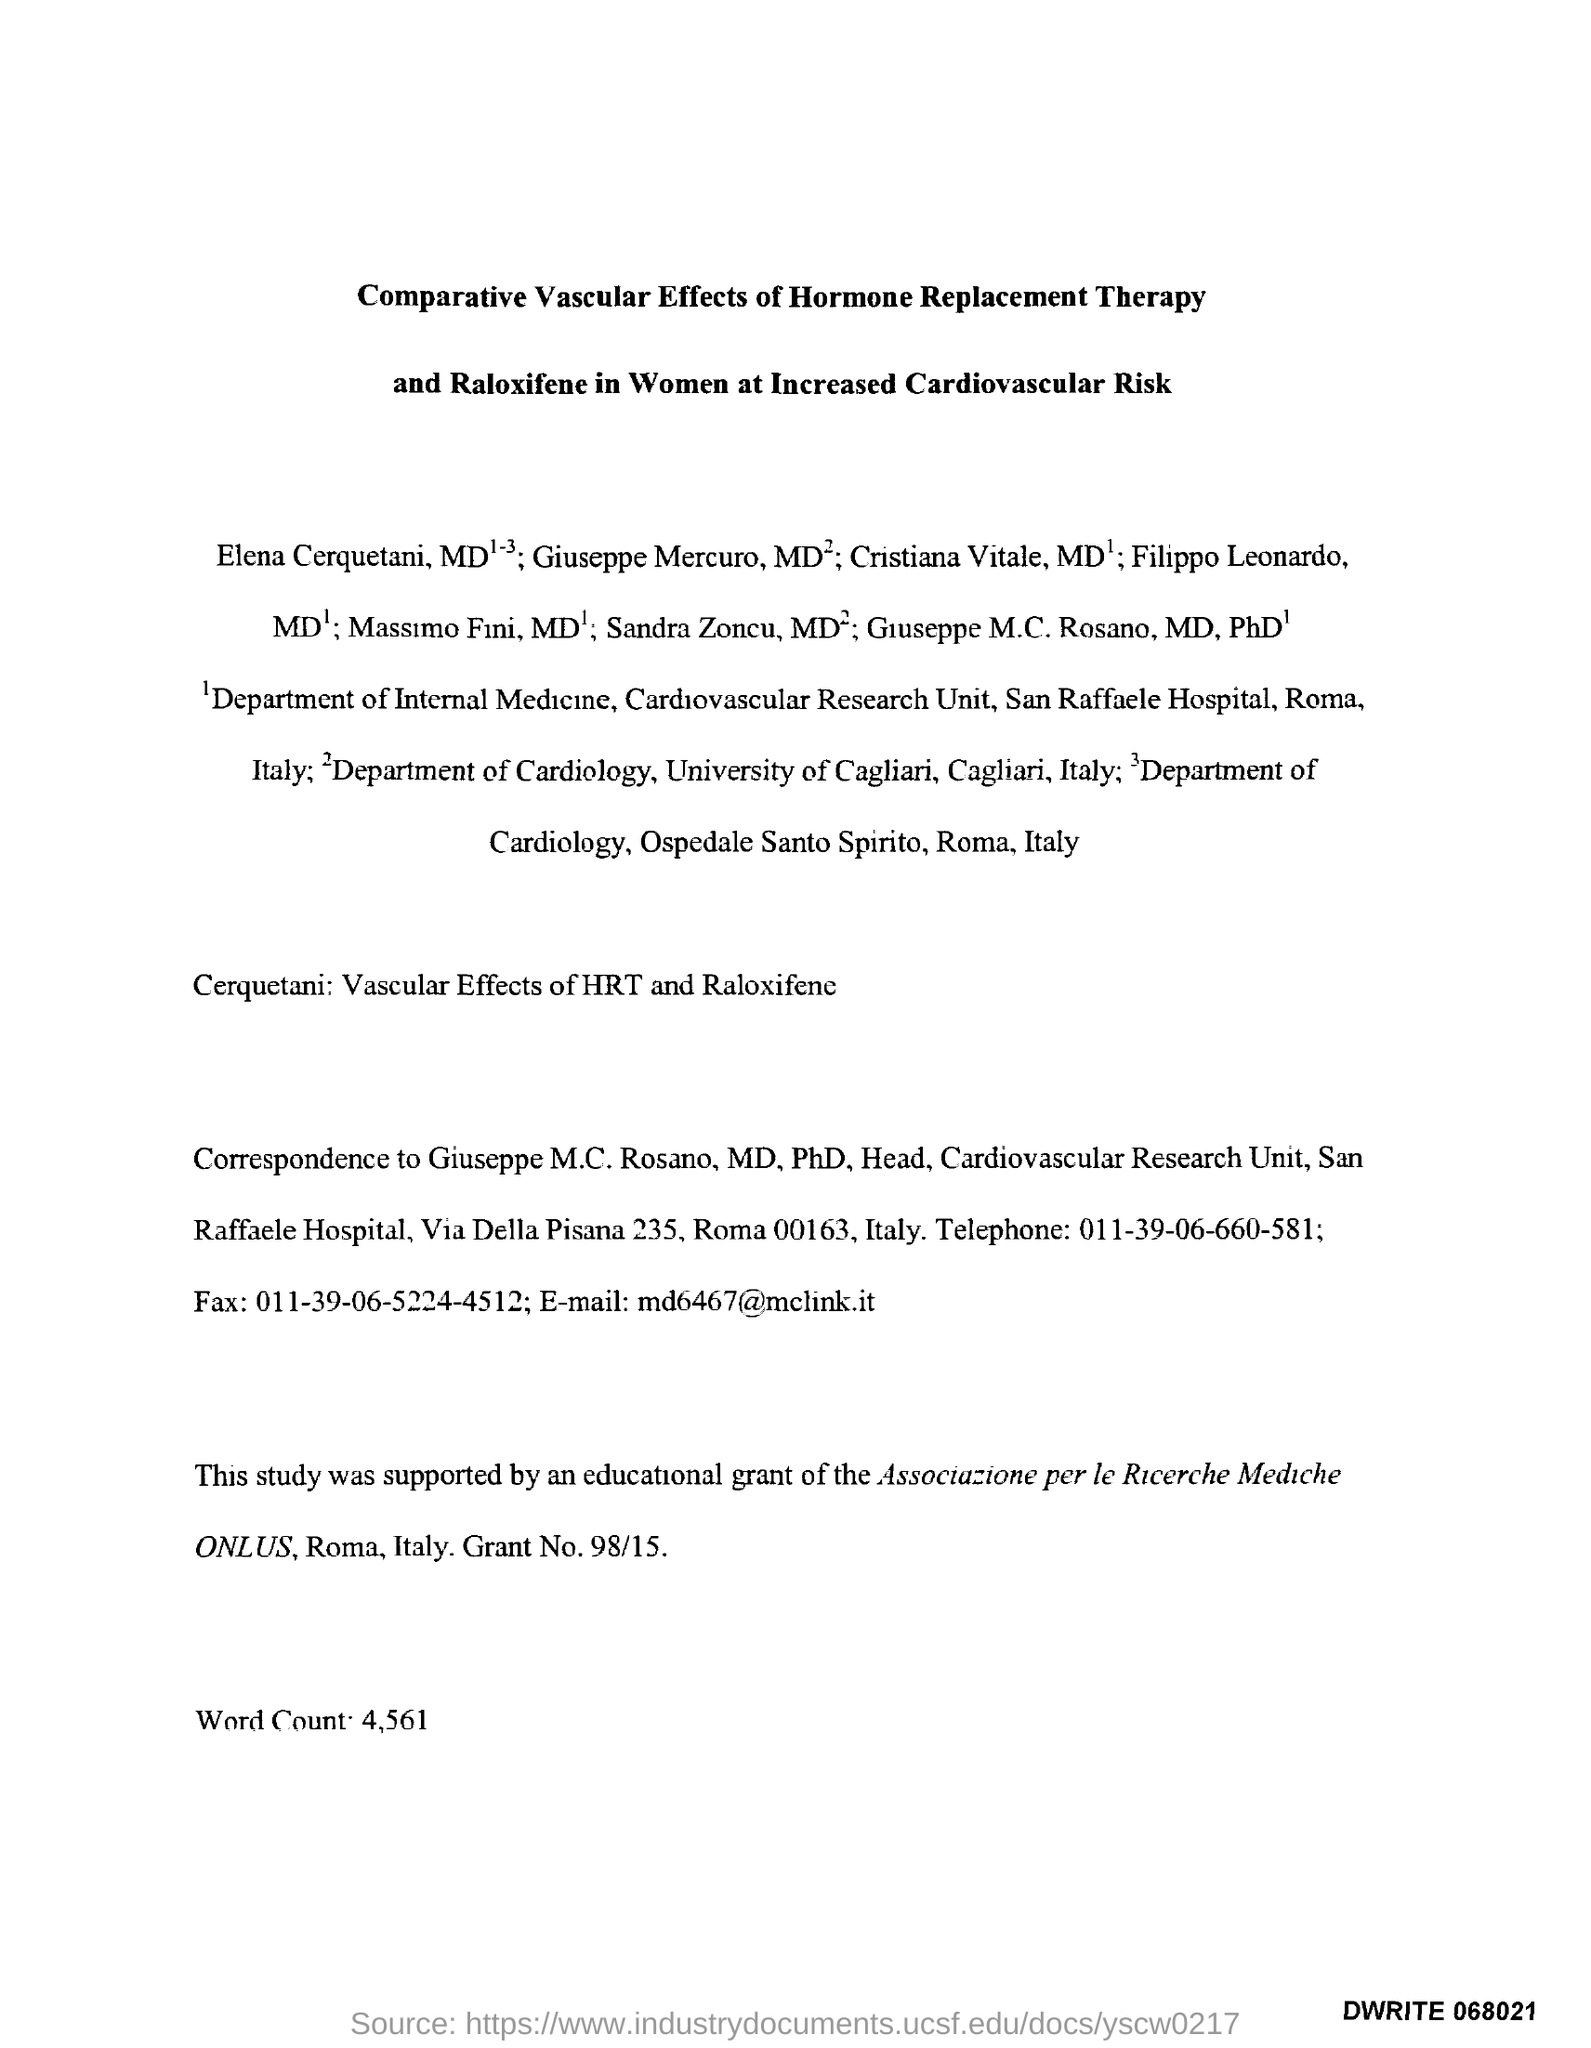What is the grant number?
Your answer should be very brief. 98/15. What is the Email id?
Keep it short and to the point. Md6467@mclink.it. What is the Fax number?
Offer a very short reply. 011-39-06-5224-4512. What is the telephone number?
Provide a succinct answer. 011-39-06-660-581. What is the word count?
Ensure brevity in your answer.  4,561. 